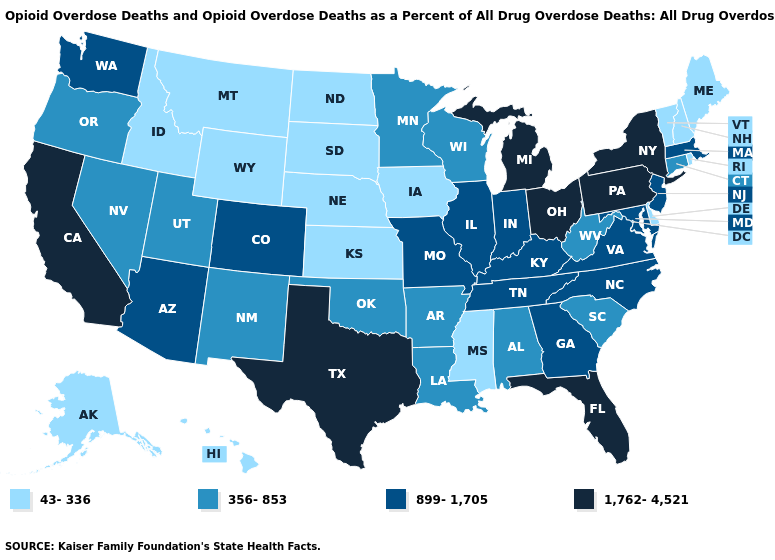Does Idaho have the lowest value in the West?
Quick response, please. Yes. Which states have the lowest value in the USA?
Concise answer only. Alaska, Delaware, Hawaii, Idaho, Iowa, Kansas, Maine, Mississippi, Montana, Nebraska, New Hampshire, North Dakota, Rhode Island, South Dakota, Vermont, Wyoming. Name the states that have a value in the range 43-336?
Short answer required. Alaska, Delaware, Hawaii, Idaho, Iowa, Kansas, Maine, Mississippi, Montana, Nebraska, New Hampshire, North Dakota, Rhode Island, South Dakota, Vermont, Wyoming. What is the lowest value in the West?
Be succinct. 43-336. Name the states that have a value in the range 43-336?
Give a very brief answer. Alaska, Delaware, Hawaii, Idaho, Iowa, Kansas, Maine, Mississippi, Montana, Nebraska, New Hampshire, North Dakota, Rhode Island, South Dakota, Vermont, Wyoming. Name the states that have a value in the range 356-853?
Keep it brief. Alabama, Arkansas, Connecticut, Louisiana, Minnesota, Nevada, New Mexico, Oklahoma, Oregon, South Carolina, Utah, West Virginia, Wisconsin. Does Connecticut have the highest value in the Northeast?
Be succinct. No. Does the map have missing data?
Answer briefly. No. Name the states that have a value in the range 356-853?
Write a very short answer. Alabama, Arkansas, Connecticut, Louisiana, Minnesota, Nevada, New Mexico, Oklahoma, Oregon, South Carolina, Utah, West Virginia, Wisconsin. Among the states that border Maryland , does West Virginia have the highest value?
Write a very short answer. No. What is the value of Missouri?
Answer briefly. 899-1,705. What is the value of Texas?
Concise answer only. 1,762-4,521. Name the states that have a value in the range 1,762-4,521?
Be succinct. California, Florida, Michigan, New York, Ohio, Pennsylvania, Texas. Among the states that border South Carolina , which have the lowest value?
Give a very brief answer. Georgia, North Carolina. Name the states that have a value in the range 356-853?
Quick response, please. Alabama, Arkansas, Connecticut, Louisiana, Minnesota, Nevada, New Mexico, Oklahoma, Oregon, South Carolina, Utah, West Virginia, Wisconsin. 